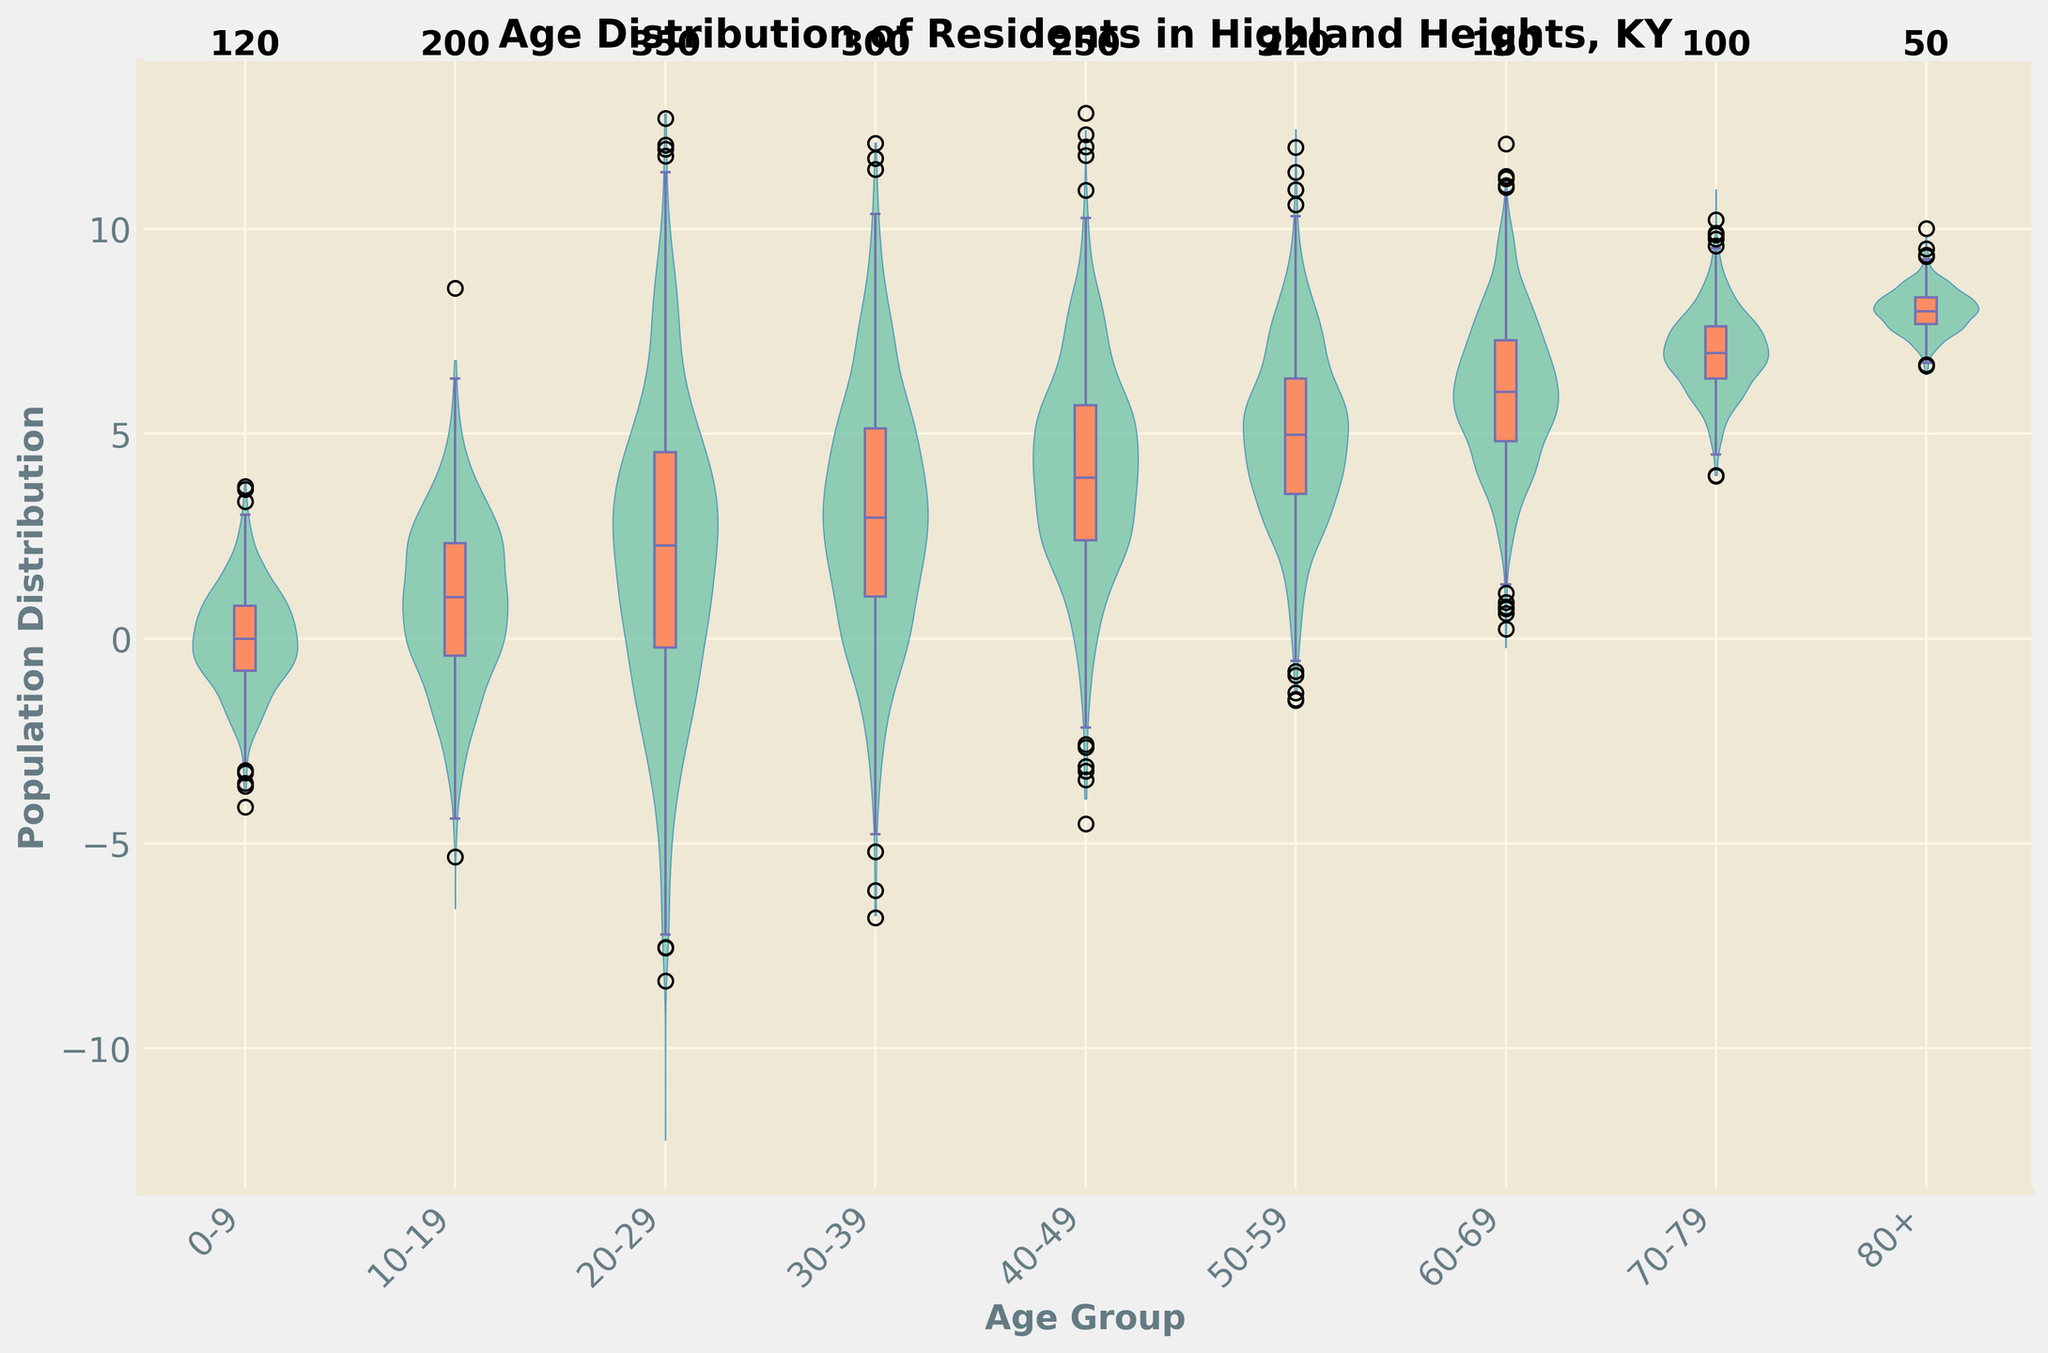What is the title of the figure? The title of the figure is displayed at the top of the plot. It reads "Age Distribution of Residents in Highland Heights, KY."
Answer: Age Distribution of Residents in Highland Heights, KY What are the labels for the x and y axes? The x-axis label is "Age Group" and the y-axis label is "Population Distribution." These labels are found directly beneath the axes.
Answer: Age Group, Population Distribution Which age group has the highest count of residents? By looking at the annotations on top of the violin plots, the age group "20-29" has the highest count of residents with 350.
Answer: 20-29 How many age groups are represented in the figure? By counting the number of distinct labels on the x-axis, there are 9 age groups represented in the figure.
Answer: 9 Which age group has the lowest count of residents? The age group "80+" has the lowest count of residents, as indicated by the number 50 annotated on the top.
Answer: 80+ What are the minimum and maximum counts of residents across all age groups? The minimum count is 50 (age group "80+") and the maximum count is 350 (age group "20-29"), which are written on the top of the violin shapes for each age group.
Answer: 50, 350 Which age groups have a count greater than or equal to 300? By reading the annotations, the age groups "20-29" with 350 and "30-39" with 300 meet this criterion.
Answer: 20-29, 30-39 How does the population distribution change as age increases? By observing the trend in the heights of the violin plots from left to right, there is an increase in population distribution up to the "20-29" age group, followed by a general decrease.
Answer: Increases then decreases What is the color of the violin plots and box plots, respectively? The violin plots are light blue-green (#66c2a5), and the box plots are light orange (#fc8d62), as seen in their shading.
Answer: Light blue-green, Light orange Which age groups have a more spread-out (i.e., wider) distribution of counts? By examining the width of the violin plots, the age groups "10-19" and "30-39" appear to have the widest distributions, suggesting more variability.
Answer: 10-19, 30-39 